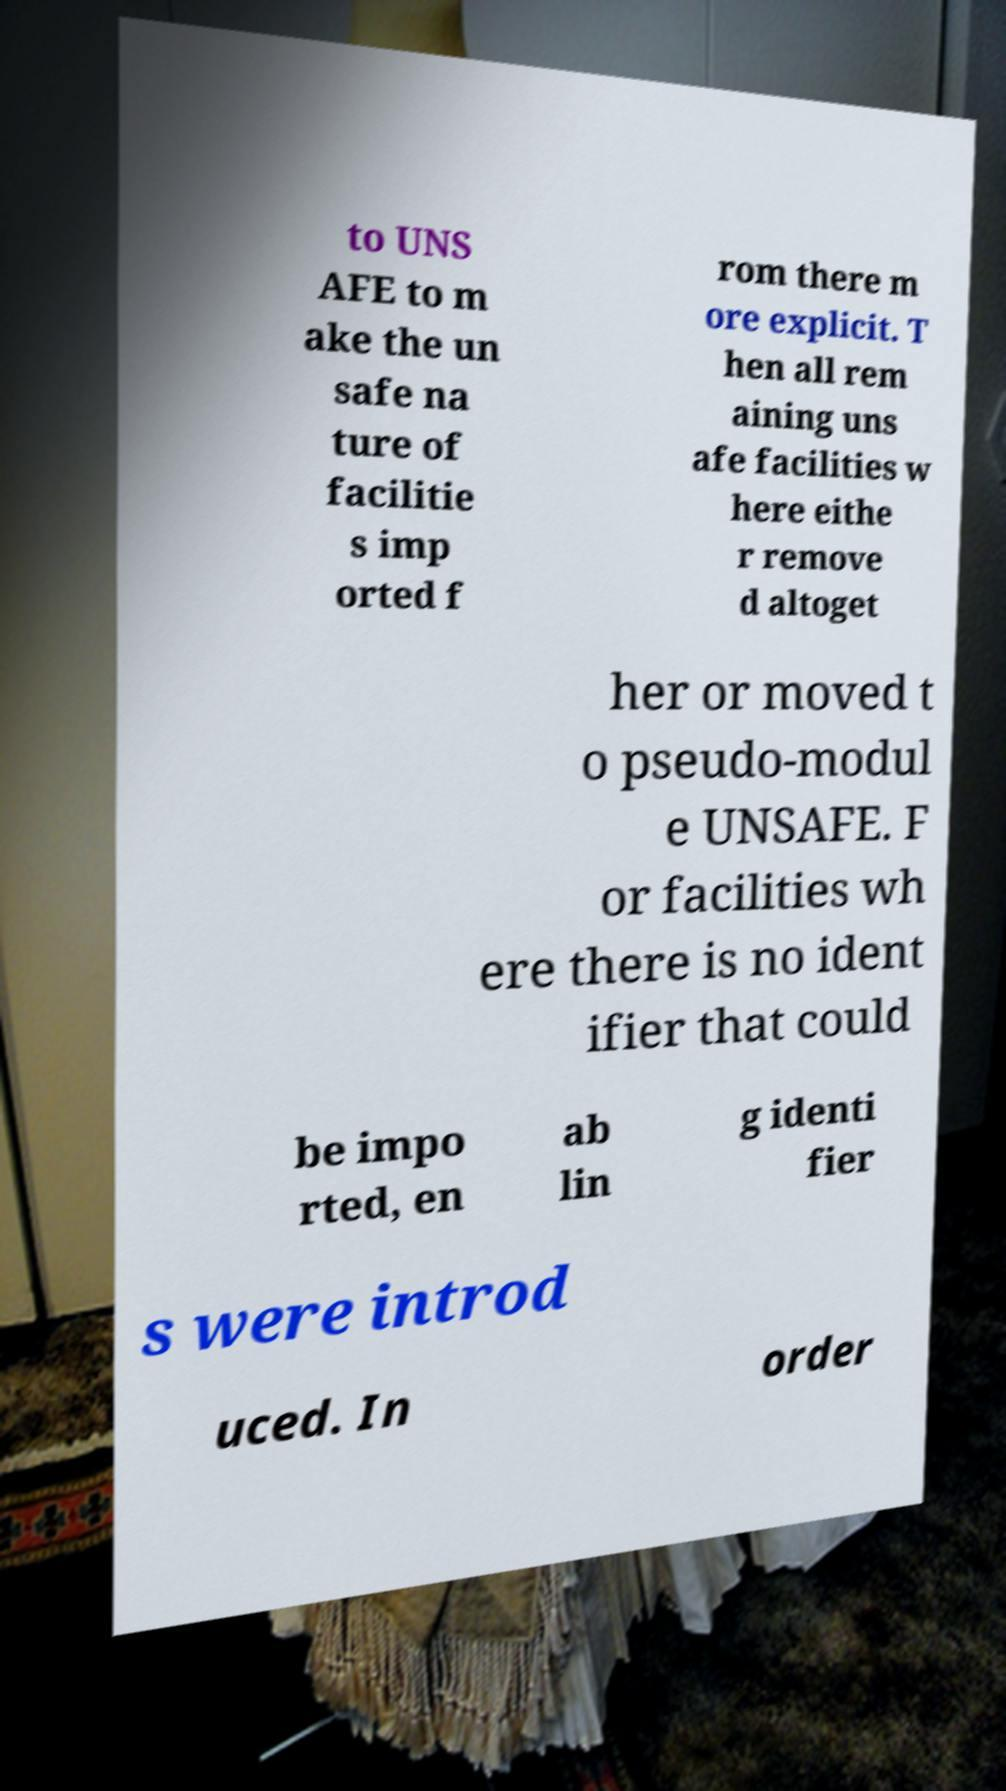For documentation purposes, I need the text within this image transcribed. Could you provide that? to UNS AFE to m ake the un safe na ture of facilitie s imp orted f rom there m ore explicit. T hen all rem aining uns afe facilities w here eithe r remove d altoget her or moved t o pseudo-modul e UNSAFE. F or facilities wh ere there is no ident ifier that could be impo rted, en ab lin g identi fier s were introd uced. In order 